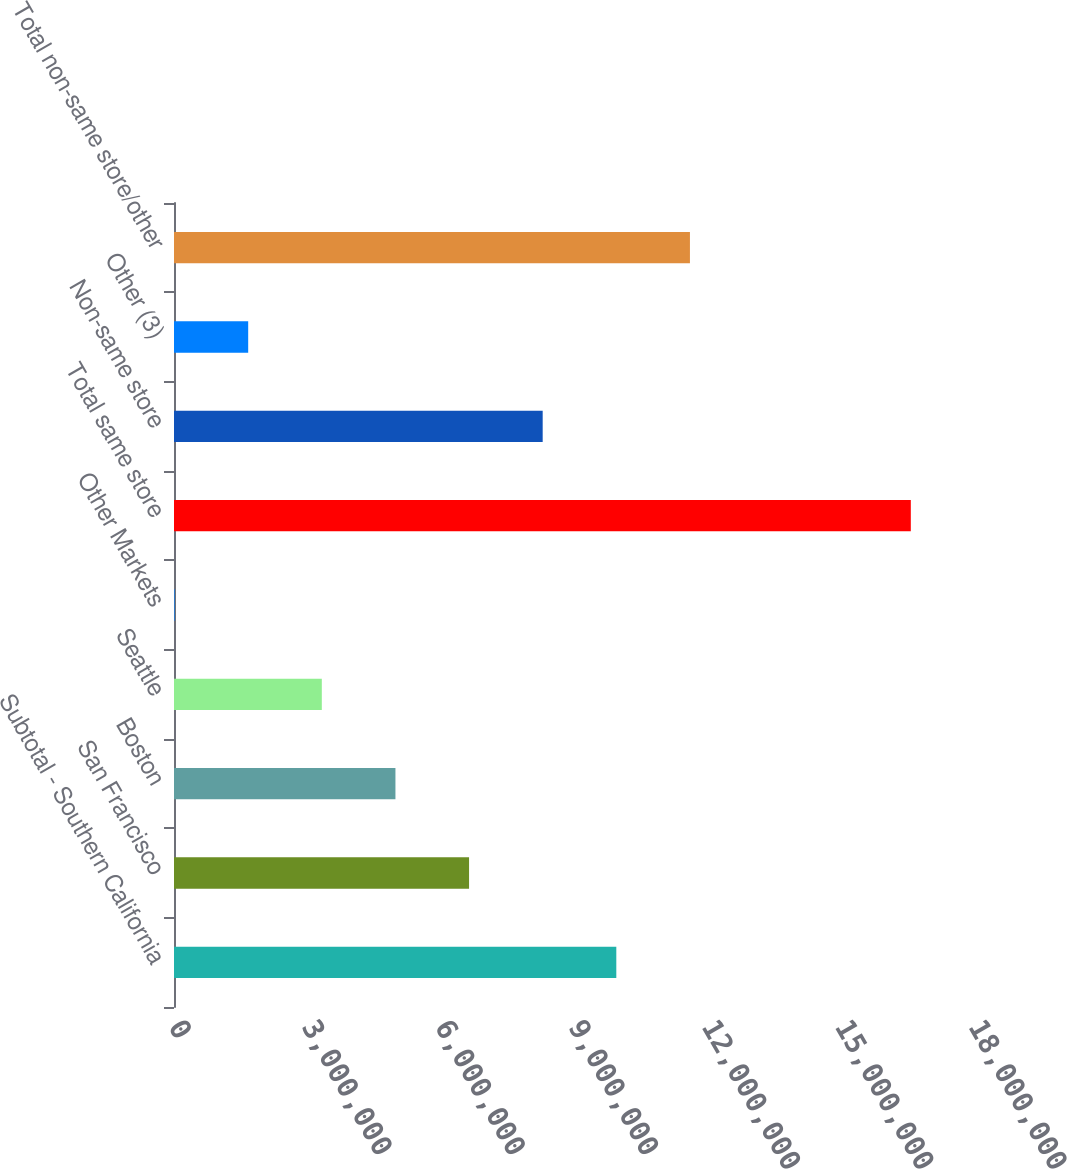Convert chart to OTSL. <chart><loc_0><loc_0><loc_500><loc_500><bar_chart><fcel>Subtotal - Southern California<fcel>San Francisco<fcel>Boston<fcel>Seattle<fcel>Other Markets<fcel>Total same store<fcel>Non-same store<fcel>Other (3)<fcel>Total non-same store/other<nl><fcel>9.95198e+06<fcel>6.63891e+06<fcel>4.98237e+06<fcel>3.32584e+06<fcel>12768<fcel>1.65781e+07<fcel>8.29545e+06<fcel>1.6693e+06<fcel>1.16085e+07<nl></chart> 